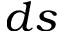<formula> <loc_0><loc_0><loc_500><loc_500>d s</formula> 